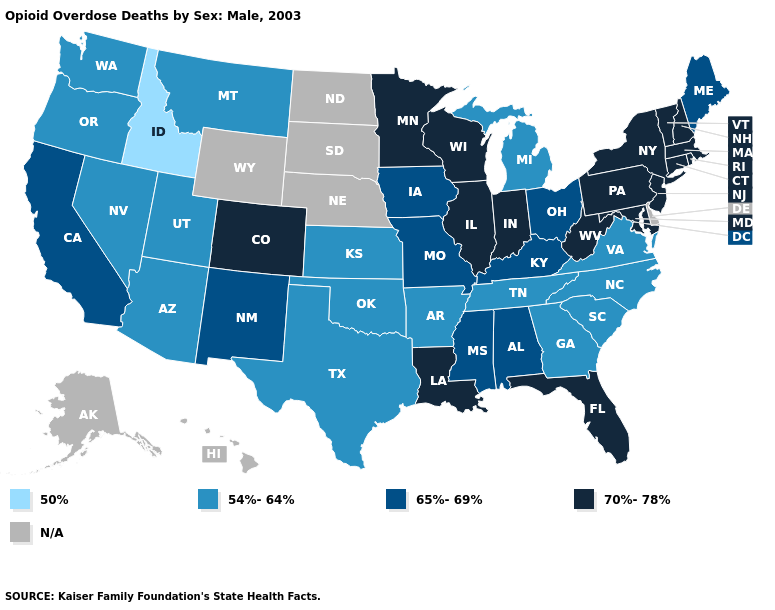What is the lowest value in states that border Georgia?
Quick response, please. 54%-64%. Which states have the highest value in the USA?
Be succinct. Colorado, Connecticut, Florida, Illinois, Indiana, Louisiana, Maryland, Massachusetts, Minnesota, New Hampshire, New Jersey, New York, Pennsylvania, Rhode Island, Vermont, West Virginia, Wisconsin. Name the states that have a value in the range 54%-64%?
Write a very short answer. Arizona, Arkansas, Georgia, Kansas, Michigan, Montana, Nevada, North Carolina, Oklahoma, Oregon, South Carolina, Tennessee, Texas, Utah, Virginia, Washington. Does Missouri have the lowest value in the USA?
Keep it brief. No. What is the highest value in the USA?
Concise answer only. 70%-78%. Does Kentucky have the lowest value in the South?
Concise answer only. No. Which states have the lowest value in the West?
Answer briefly. Idaho. What is the value of Vermont?
Concise answer only. 70%-78%. Name the states that have a value in the range 70%-78%?
Quick response, please. Colorado, Connecticut, Florida, Illinois, Indiana, Louisiana, Maryland, Massachusetts, Minnesota, New Hampshire, New Jersey, New York, Pennsylvania, Rhode Island, Vermont, West Virginia, Wisconsin. Among the states that border Nebraska , does Kansas have the lowest value?
Give a very brief answer. Yes. Which states have the highest value in the USA?
Give a very brief answer. Colorado, Connecticut, Florida, Illinois, Indiana, Louisiana, Maryland, Massachusetts, Minnesota, New Hampshire, New Jersey, New York, Pennsylvania, Rhode Island, Vermont, West Virginia, Wisconsin. Name the states that have a value in the range 70%-78%?
Short answer required. Colorado, Connecticut, Florida, Illinois, Indiana, Louisiana, Maryland, Massachusetts, Minnesota, New Hampshire, New Jersey, New York, Pennsylvania, Rhode Island, Vermont, West Virginia, Wisconsin. Name the states that have a value in the range N/A?
Be succinct. Alaska, Delaware, Hawaii, Nebraska, North Dakota, South Dakota, Wyoming. Which states have the lowest value in the West?
Concise answer only. Idaho. 